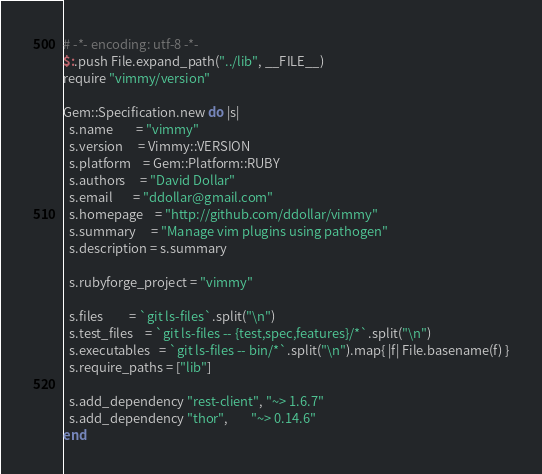<code> <loc_0><loc_0><loc_500><loc_500><_Ruby_># -*- encoding: utf-8 -*-
$:.push File.expand_path("../lib", __FILE__)
require "vimmy/version"

Gem::Specification.new do |s|
  s.name        = "vimmy"
  s.version     = Vimmy::VERSION
  s.platform    = Gem::Platform::RUBY
  s.authors     = "David Dollar"
  s.email       = "ddollar@gmail.com"
  s.homepage    = "http://github.com/ddollar/vimmy"
  s.summary     = "Manage vim plugins using pathogen"
  s.description = s.summary

  s.rubyforge_project = "vimmy"

  s.files         = `git ls-files`.split("\n")
  s.test_files    = `git ls-files -- {test,spec,features}/*`.split("\n")
  s.executables   = `git ls-files -- bin/*`.split("\n").map{ |f| File.basename(f) }
  s.require_paths = ["lib"]

  s.add_dependency "rest-client", "~> 1.6.7"
  s.add_dependency "thor",        "~> 0.14.6"
end
</code> 